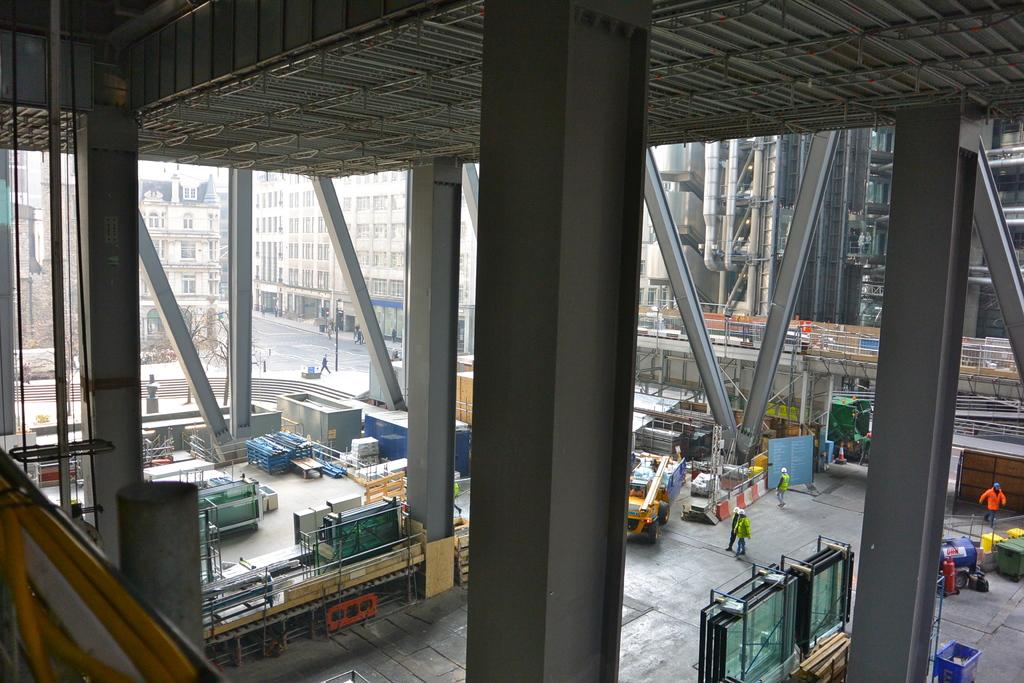What type of structures can be seen in the image? There are buildings in the image. What architectural features can be observed on the buildings? Windows are visible in the image. What type of vegetation is present in the image? There are trees in the image. What type of street furniture can be seen in the image? There are poles in the image. What type of storage containers are present in the image? There are colorful containers in the image. What type of transportation is visible in the image? There is a vehicle in the image. What type of waste disposal units are present in the image? There are dustbins in the image. What type of fuel source can be seen in the image? There are wooden-logs in the image. What type of signage is present in the image? There is a board in the image. What type of traffic control device is present in the image? There is a traffic cone in the image. Are there any people present in the image? Yes, there are people in the image. Are there any other objects present in the image besides the ones mentioned? Yes, there are other objects in the image. How many crates are stacked on top of each other in the image? There are no crates present in the image. What type of copy machine can be seen in the image? There is no copy machine present in the image. 